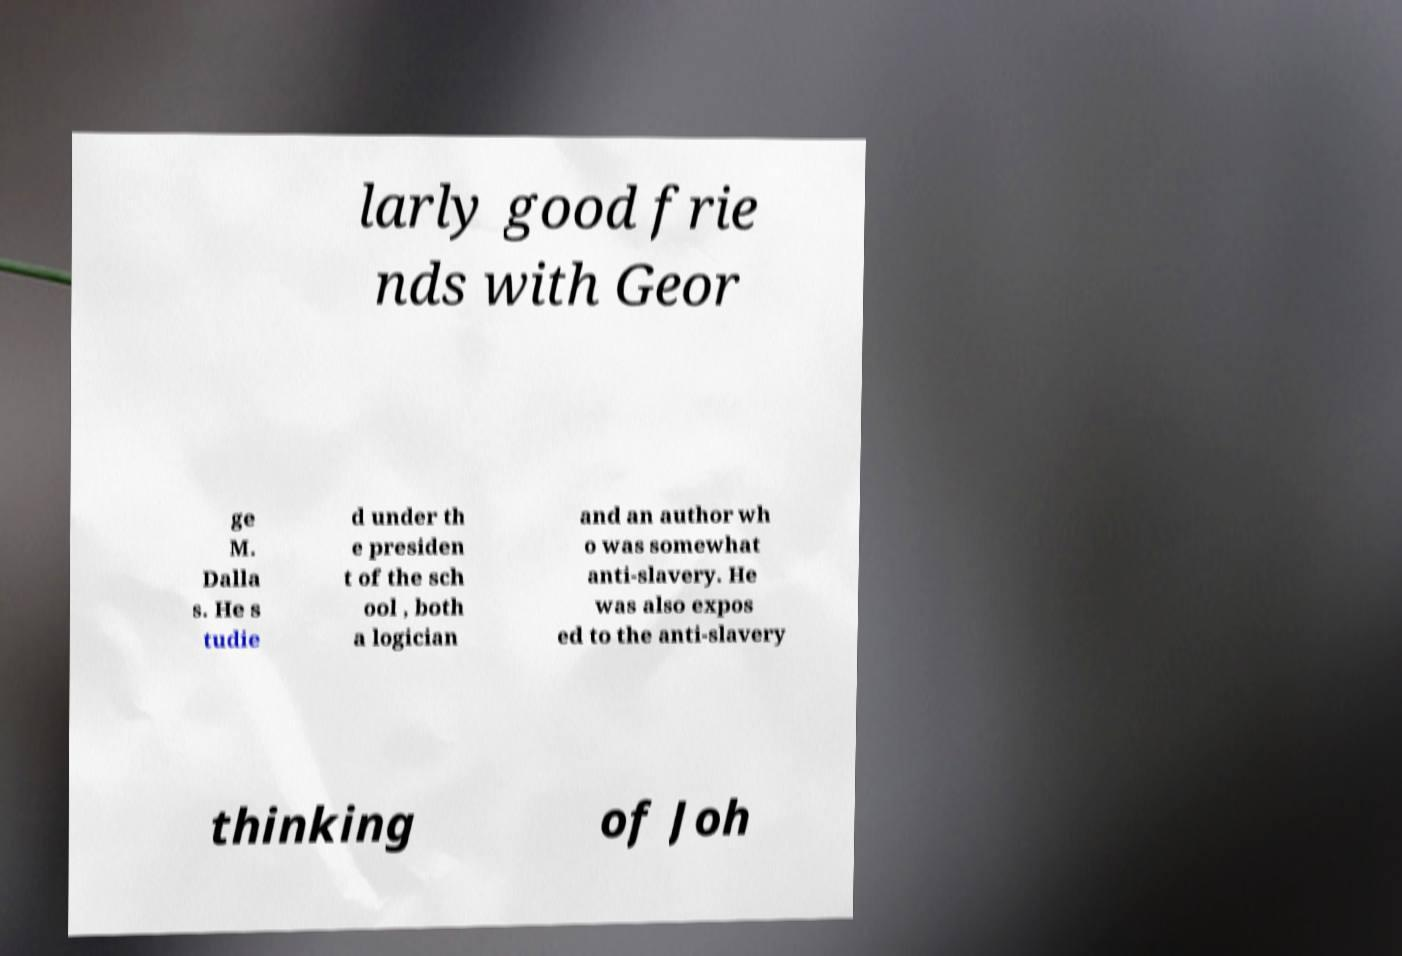Can you read and provide the text displayed in the image?This photo seems to have some interesting text. Can you extract and type it out for me? larly good frie nds with Geor ge M. Dalla s. He s tudie d under th e presiden t of the sch ool , both a logician and an author wh o was somewhat anti-slavery. He was also expos ed to the anti-slavery thinking of Joh 